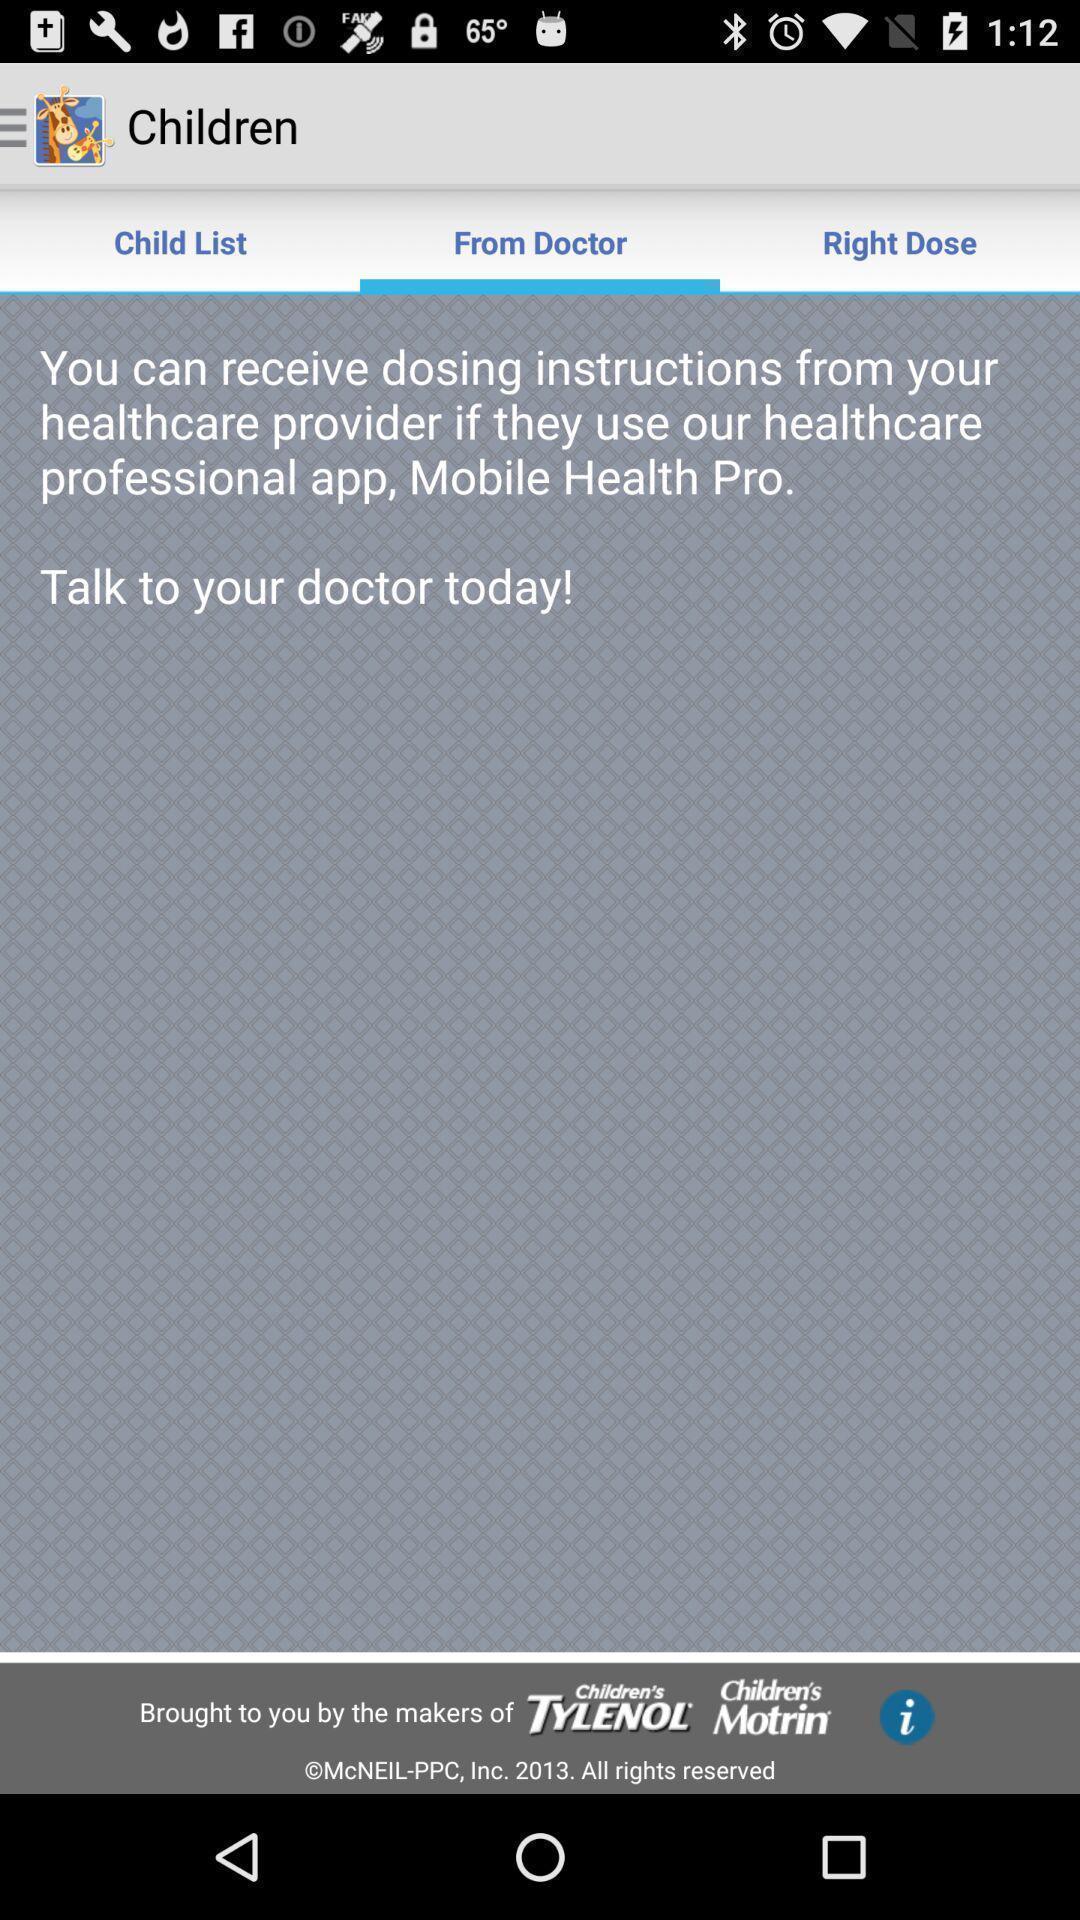Summarize the information in this screenshot. Page with instruction of doctor for a health app. 